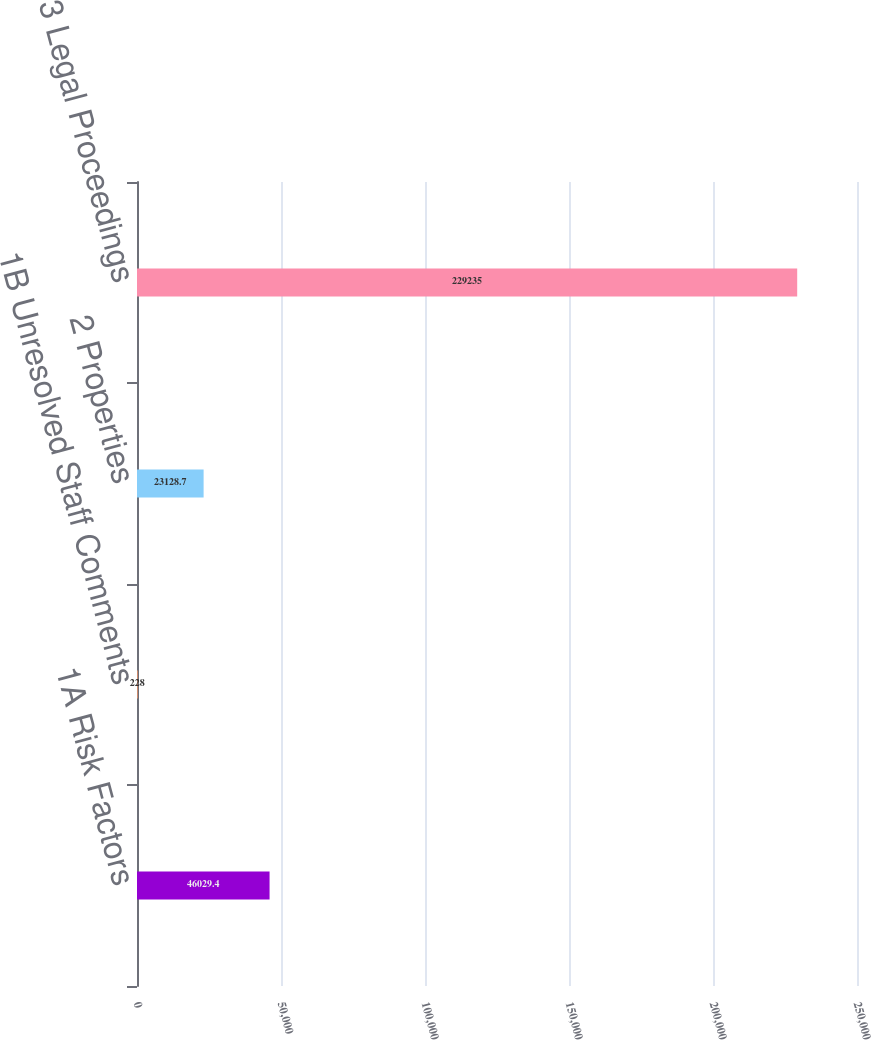<chart> <loc_0><loc_0><loc_500><loc_500><bar_chart><fcel>1A Risk Factors<fcel>1B Unresolved Staff Comments<fcel>2 Properties<fcel>3 Legal Proceedings<nl><fcel>46029.4<fcel>228<fcel>23128.7<fcel>229235<nl></chart> 